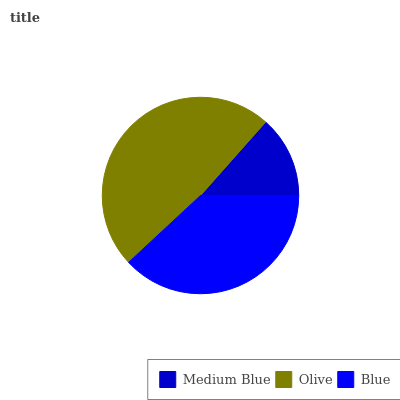Is Medium Blue the minimum?
Answer yes or no. Yes. Is Olive the maximum?
Answer yes or no. Yes. Is Blue the minimum?
Answer yes or no. No. Is Blue the maximum?
Answer yes or no. No. Is Olive greater than Blue?
Answer yes or no. Yes. Is Blue less than Olive?
Answer yes or no. Yes. Is Blue greater than Olive?
Answer yes or no. No. Is Olive less than Blue?
Answer yes or no. No. Is Blue the high median?
Answer yes or no. Yes. Is Blue the low median?
Answer yes or no. Yes. Is Medium Blue the high median?
Answer yes or no. No. Is Olive the low median?
Answer yes or no. No. 